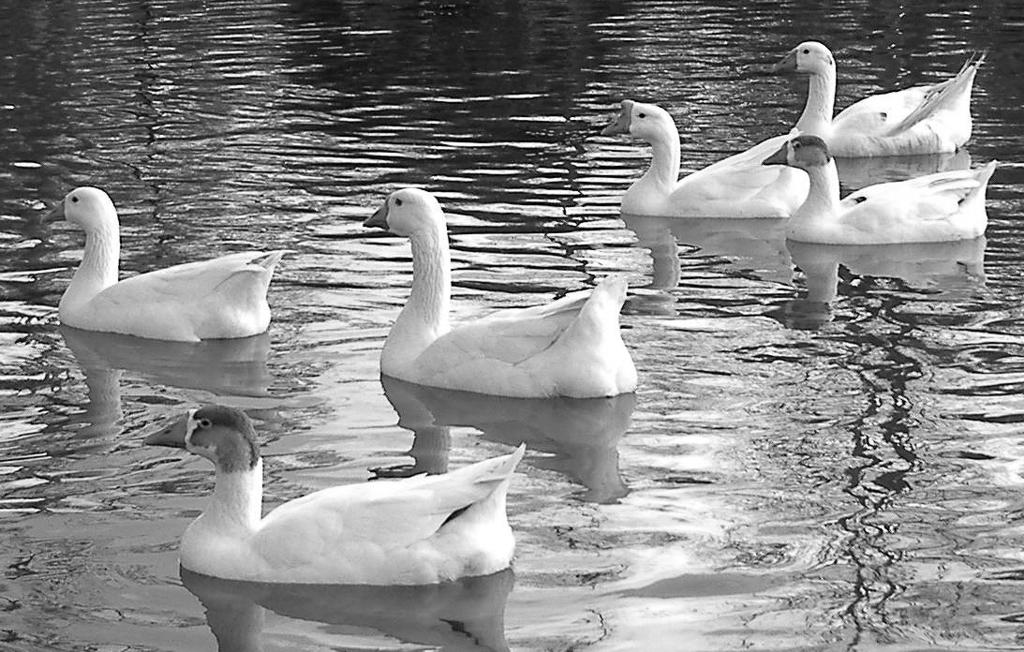What type of animals can be seen in the image? Birds can be seen in the water in the image. What is the color scheme of the image? The image is black and white. How many buttons can be seen on the birds in the image? There are no buttons visible on the birds in the image, as birds do not have buttons. 